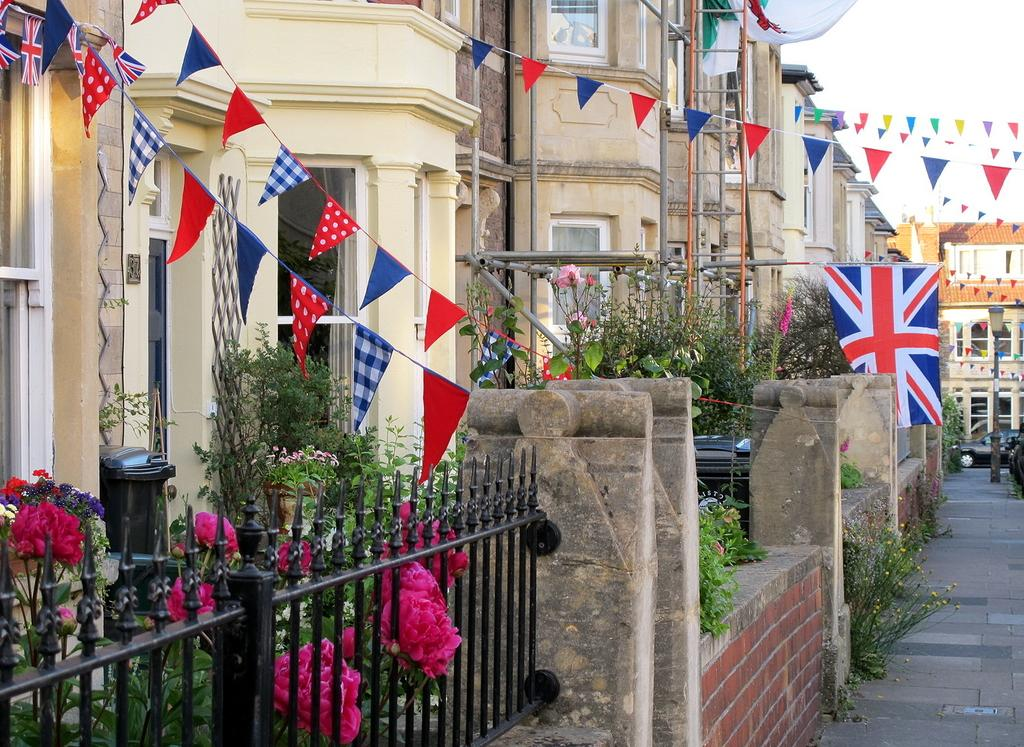What can be seen in the sky in the image? There is sky visible in the image. What type of structures are present in the image? There are buildings in the image. What is the purpose of the street pole in the image? The street pole in the image is likely used for holding street lights or other signs. What type of lighting is present in the image? There are street lights in the image. What is the grill used for in the image? The grill in the image is likely used for cooking food. What type of waste disposal units are present in the image? There are bins in the image. What type of vegetation can be seen in the image? There are trees, plants, and flowers in the image. What type of surface is present for walking or driving in the image? There is grass and a road in the image. What type of decorations are present in the image? There are decorations in the image. Where is the school located in the image? There is no school present in the image. What type of judgment is the judge making in the image? There is no judge or any judicial activity present in the image. 